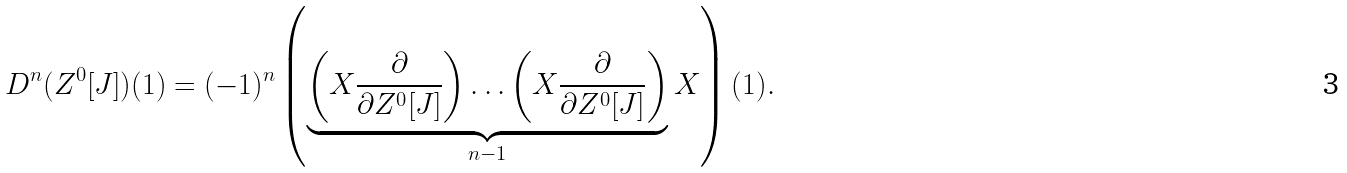Convert formula to latex. <formula><loc_0><loc_0><loc_500><loc_500>D ^ { n } ( Z ^ { 0 } [ J ] ) ( 1 ) = ( - 1 ) ^ { n } \left ( \underbrace { \left ( X \frac { \partial } { \partial Z ^ { 0 } [ J ] } \right ) \dots \left ( X \frac { \partial } { \partial Z ^ { 0 } [ J ] } \right ) } _ { n - 1 } X \right ) ( 1 ) .</formula> 